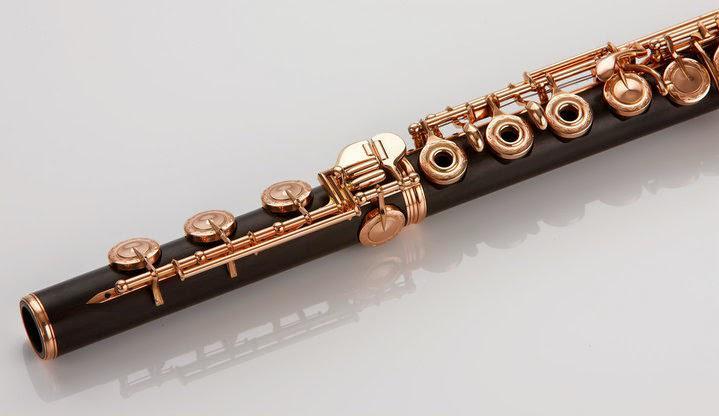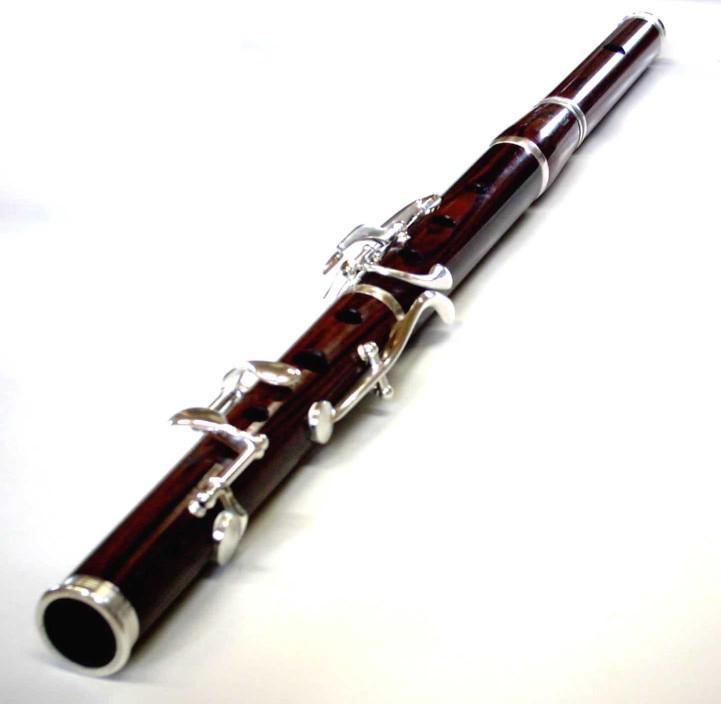The first image is the image on the left, the second image is the image on the right. Considering the images on both sides, is "Each image contains exactly one dark flute with metal keys." valid? Answer yes or no. Yes. The first image is the image on the left, the second image is the image on the right. For the images displayed, is the sentence "There are two very dark colored flutes." factually correct? Answer yes or no. Yes. 